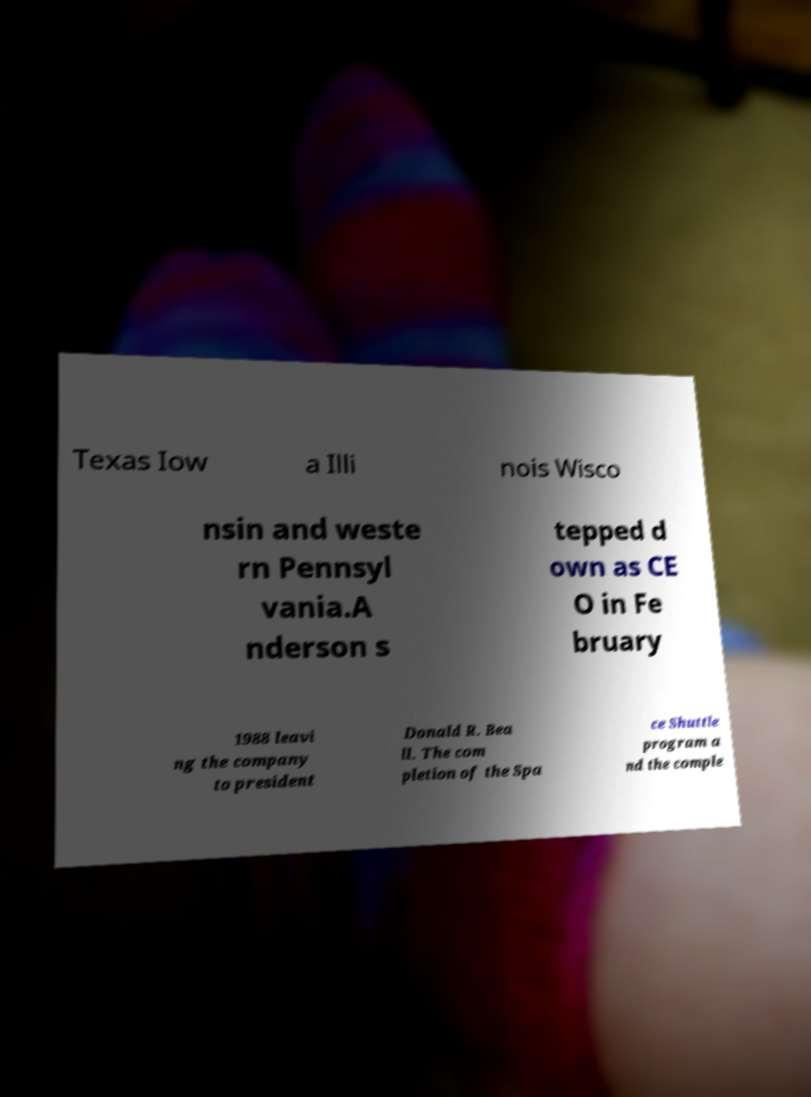Can you read and provide the text displayed in the image?This photo seems to have some interesting text. Can you extract and type it out for me? Texas Iow a Illi nois Wisco nsin and weste rn Pennsyl vania.A nderson s tepped d own as CE O in Fe bruary 1988 leavi ng the company to president Donald R. Bea ll. The com pletion of the Spa ce Shuttle program a nd the comple 